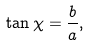Convert formula to latex. <formula><loc_0><loc_0><loc_500><loc_500>\tan \chi = \frac { b } { a } ,</formula> 